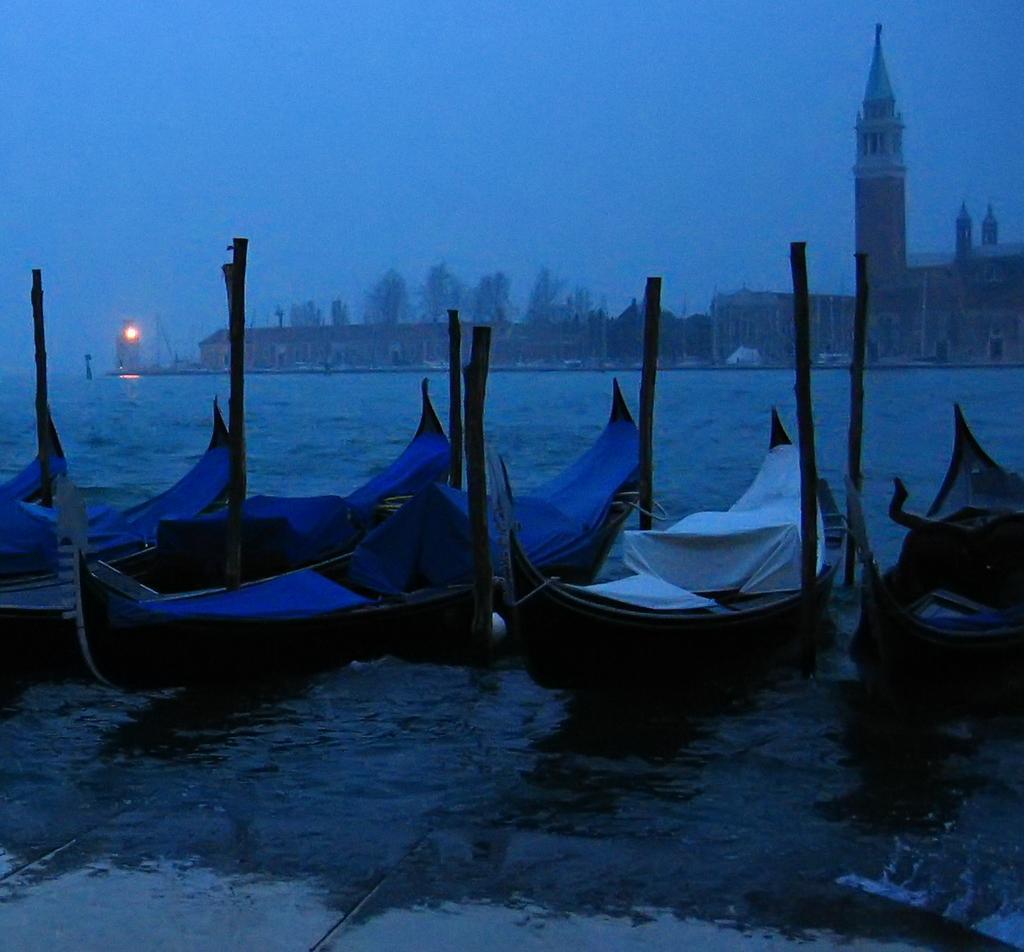Describe this image in one or two sentences. In this picture we can see boats on the water, buildings, trees, light and some objects and in the background we can see the sky. 